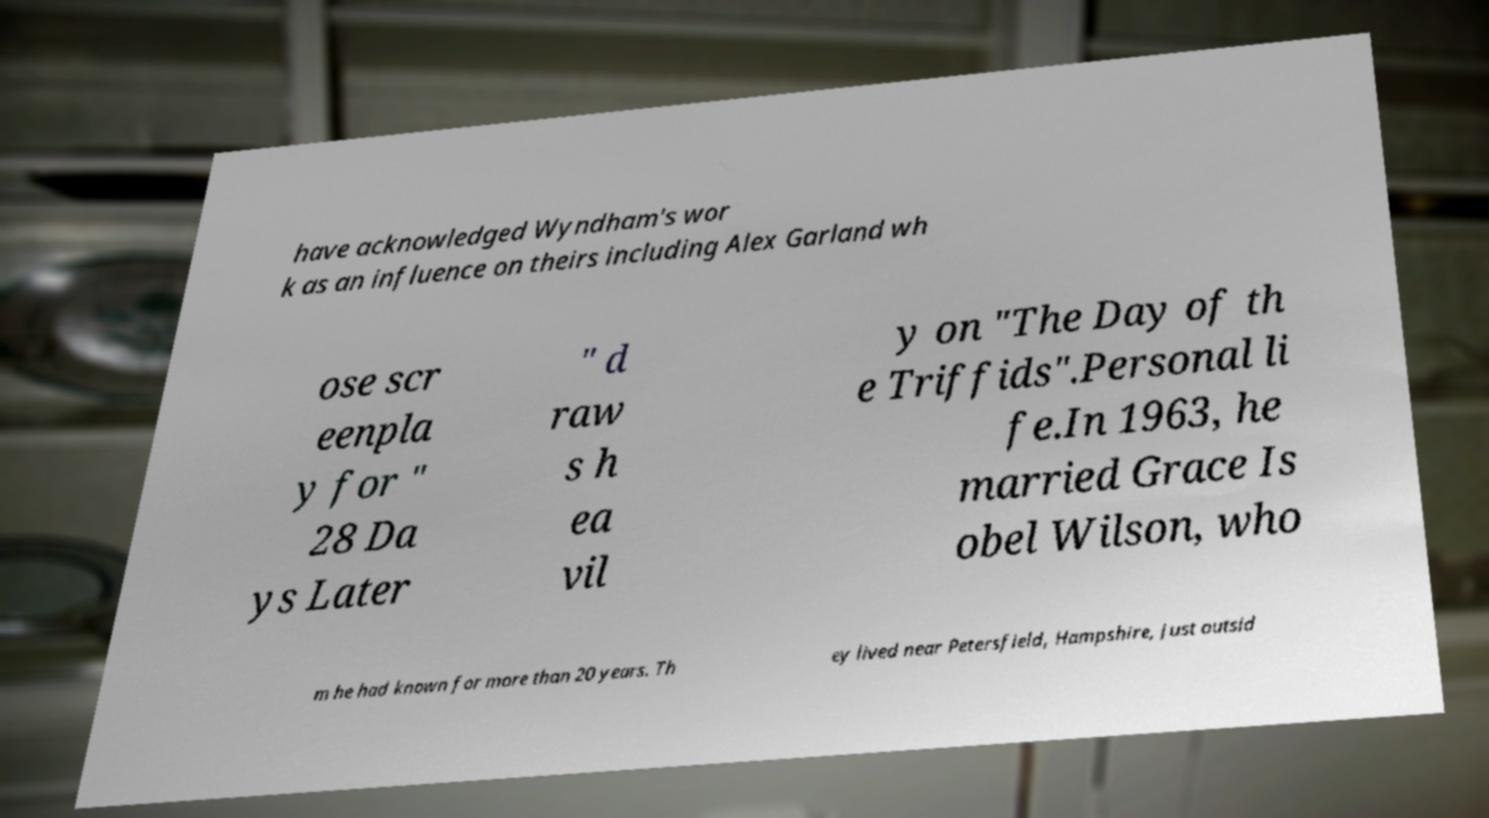Could you extract and type out the text from this image? have acknowledged Wyndham's wor k as an influence on theirs including Alex Garland wh ose scr eenpla y for " 28 Da ys Later " d raw s h ea vil y on "The Day of th e Triffids".Personal li fe.In 1963, he married Grace Is obel Wilson, who m he had known for more than 20 years. Th ey lived near Petersfield, Hampshire, just outsid 